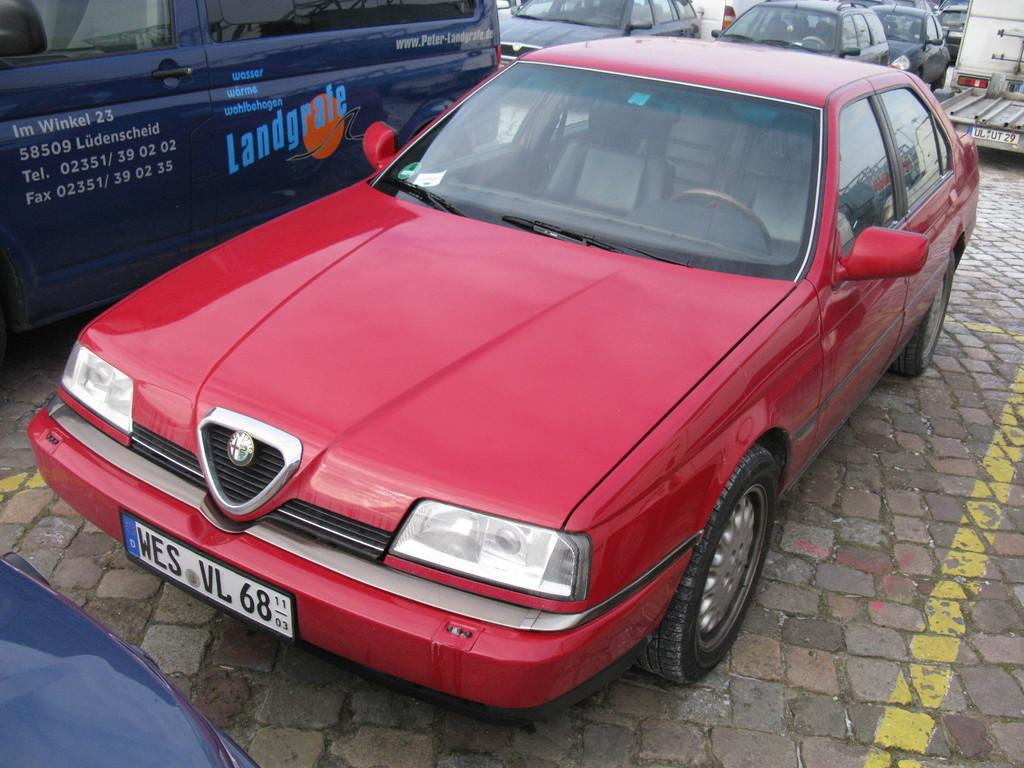Where was the image taken? The image was clicked outside. What can be seen on the ground in the image? There is a group of vehicles parked on the ground. Can you describe one of the vehicles in the image? There is a blue color vehicle among the parked vehicles. What additional details can be observed on the blue vehicle? Text and numbers are visible on the blue color vehicle. What type of pickle is being used to teach education in the image? There is no pickle or reference to education in the image; it features a group of parked vehicles. 